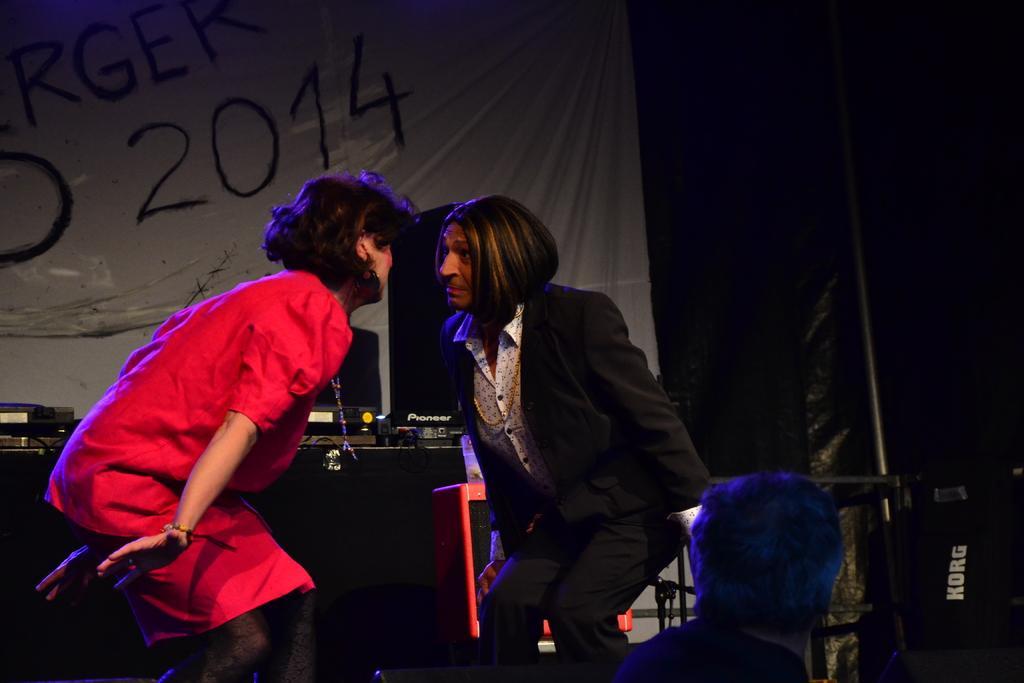Could you give a brief overview of what you see in this image? In this image I can see two people are wearing red, black and white color dresses. Back I can see few objects and the white color banner. Background is black in color. 